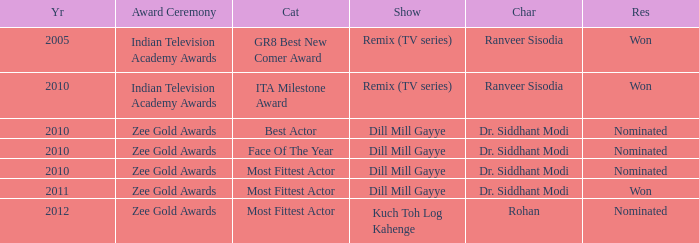Which show has a character of Rohan? Kuch Toh Log Kahenge. 